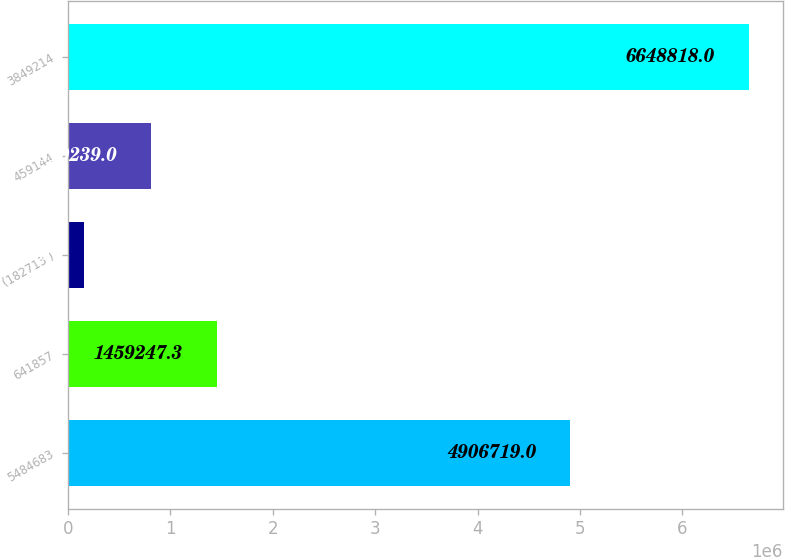Convert chart. <chart><loc_0><loc_0><loc_500><loc_500><bar_chart><fcel>5484683<fcel>641857<fcel>(182713 )<fcel>459144<fcel>3849214<nl><fcel>4.90672e+06<fcel>1.45925e+06<fcel>158735<fcel>810239<fcel>6.64882e+06<nl></chart> 